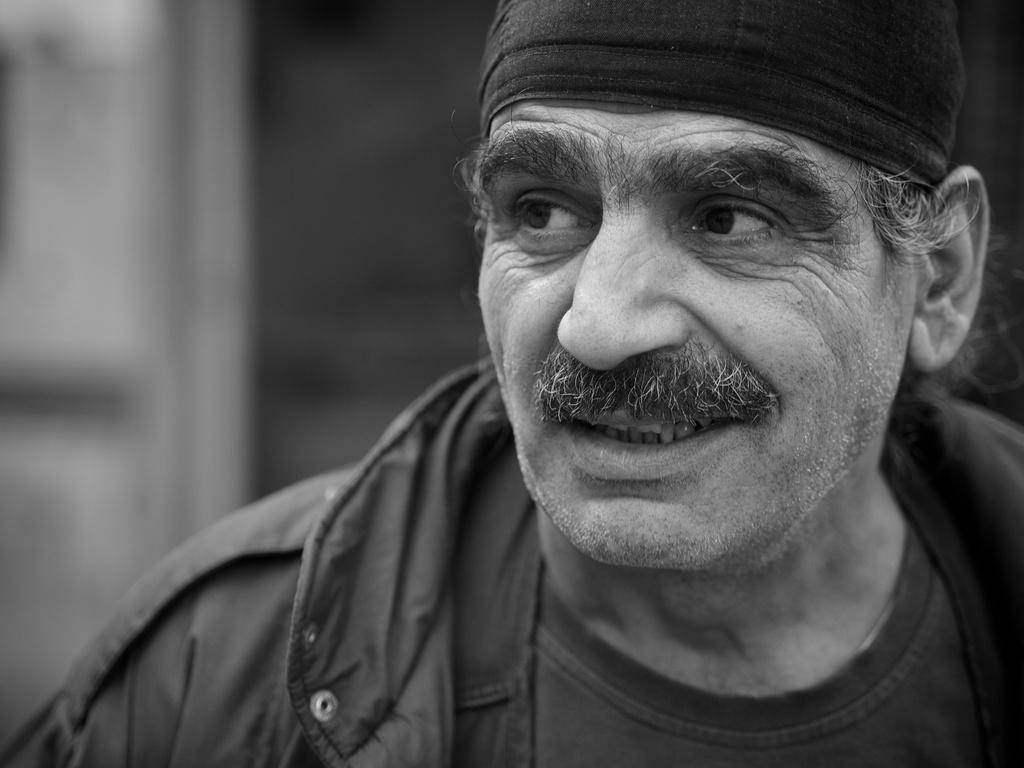In one or two sentences, can you explain what this image depicts? In this black and white picture there is a person wearing a jacket and a cap. Background is blurry. 